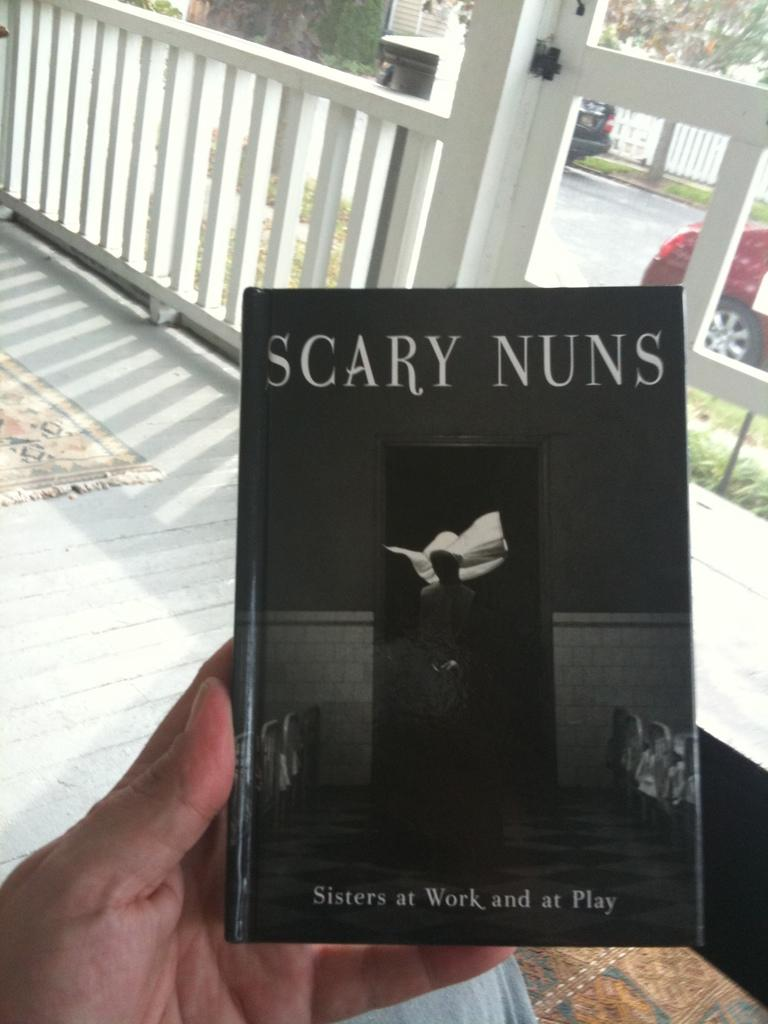<image>
Offer a succinct explanation of the picture presented. a book that has the title 'scary nuns' at the top of it 